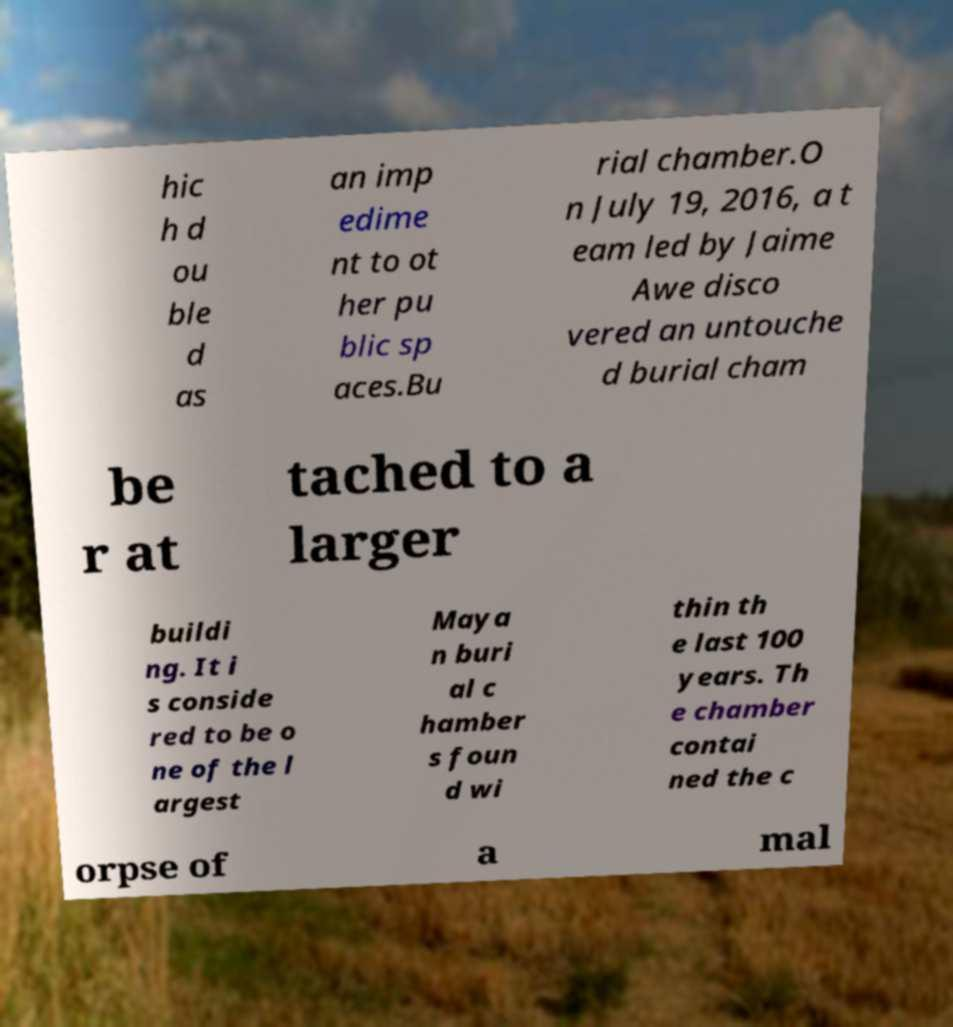Could you extract and type out the text from this image? hic h d ou ble d as an imp edime nt to ot her pu blic sp aces.Bu rial chamber.O n July 19, 2016, a t eam led by Jaime Awe disco vered an untouche d burial cham be r at tached to a larger buildi ng. It i s conside red to be o ne of the l argest Maya n buri al c hamber s foun d wi thin th e last 100 years. Th e chamber contai ned the c orpse of a mal 